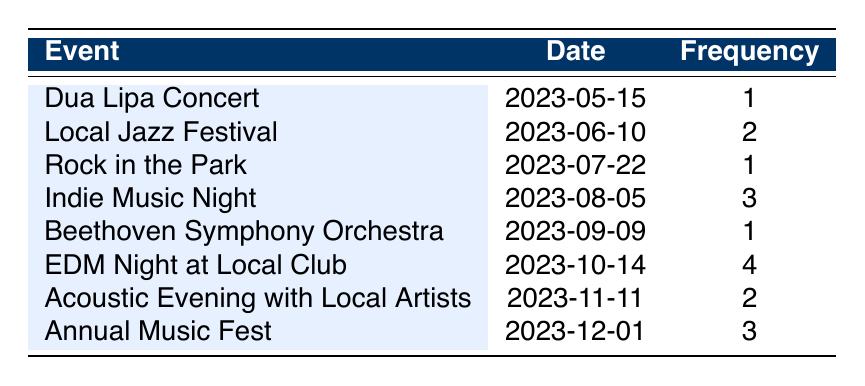What was the total frequency of attending live music events? To find the total frequency, we sum up the values from the frequency column: 1 + 2 + 1 + 3 + 1 + 4 + 2 + 3 = 17.
Answer: 17 Which live music event had the highest attendance frequency? The event with the highest frequency is "EDM Night at Local Club," which has a frequency of 4.
Answer: EDM Night at Local Club How many times did you attend events in August? In August, there is one event, "Indie Music Night," with a frequency of 3. Therefore, attendance in August is 3.
Answer: 3 Is the frequency of attending the "Local Jazz Festival" greater than that of the "Rock in the Park"? The frequency for the "Local Jazz Festival" is 2, while the frequency for "Rock in the Park" is 1. Since 2 is greater than 1, the statement is true.
Answer: Yes What is the average frequency of attending events throughout the year? To find the average frequency, we divide the total frequency (17) by the number of events (8): 17/8 = 2.125.
Answer: 2.125 How many events had a frequency of 2 or higher? The events with a frequency of 2 or higher are: "Local Jazz Festival" (2), "Indie Music Night" (3), "EDM Night at Local Club" (4), "Acoustic Evening with Local Artists" (2), and "Annual Music Fest" (3). That's a total of 5 events.
Answer: 5 Did you attend any classical music events? The "Beethoven Symphony Orchestra" is a classical music event with a frequency of 1, indicating attendance at this event. Therefore, the answer is yes.
Answer: Yes How many more times did you attend "Indie Music Night" compared to "Dua Lipa Concert"? "Indie Music Night" has a frequency of 3, while "Dua Lipa Concert" has a frequency of 1. The difference is 3 - 1 = 2.
Answer: 2 Which month had the most live music events? In the provided data, there is one event per month except for October (EDM Night at Local Club) with a frequency of the highest attendance (4). Since there is only one event per month listed, the month with the most attendance would be October due to its frequency.
Answer: October 